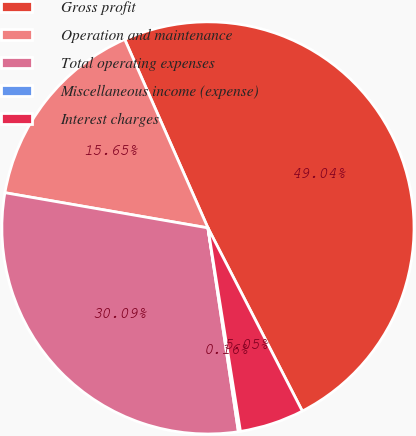Convert chart. <chart><loc_0><loc_0><loc_500><loc_500><pie_chart><fcel>Gross profit<fcel>Operation and maintenance<fcel>Total operating expenses<fcel>Miscellaneous income (expense)<fcel>Interest charges<nl><fcel>49.04%<fcel>15.65%<fcel>30.09%<fcel>0.16%<fcel>5.05%<nl></chart> 